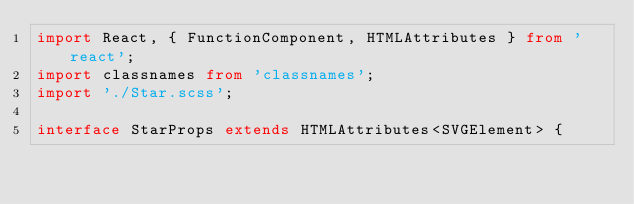<code> <loc_0><loc_0><loc_500><loc_500><_TypeScript_>import React, { FunctionComponent, HTMLAttributes } from 'react';
import classnames from 'classnames';
import './Star.scss';

interface StarProps extends HTMLAttributes<SVGElement> {</code> 